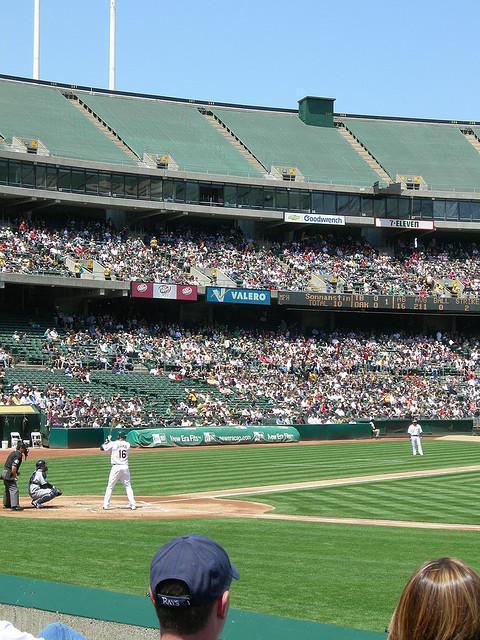How many people are there?
Give a very brief answer. 2. 